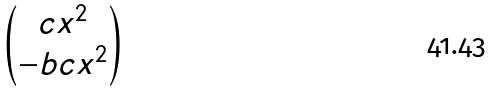<formula> <loc_0><loc_0><loc_500><loc_500>\begin{pmatrix} c x ^ { 2 } \\ - b c x ^ { 2 } \end{pmatrix}</formula> 